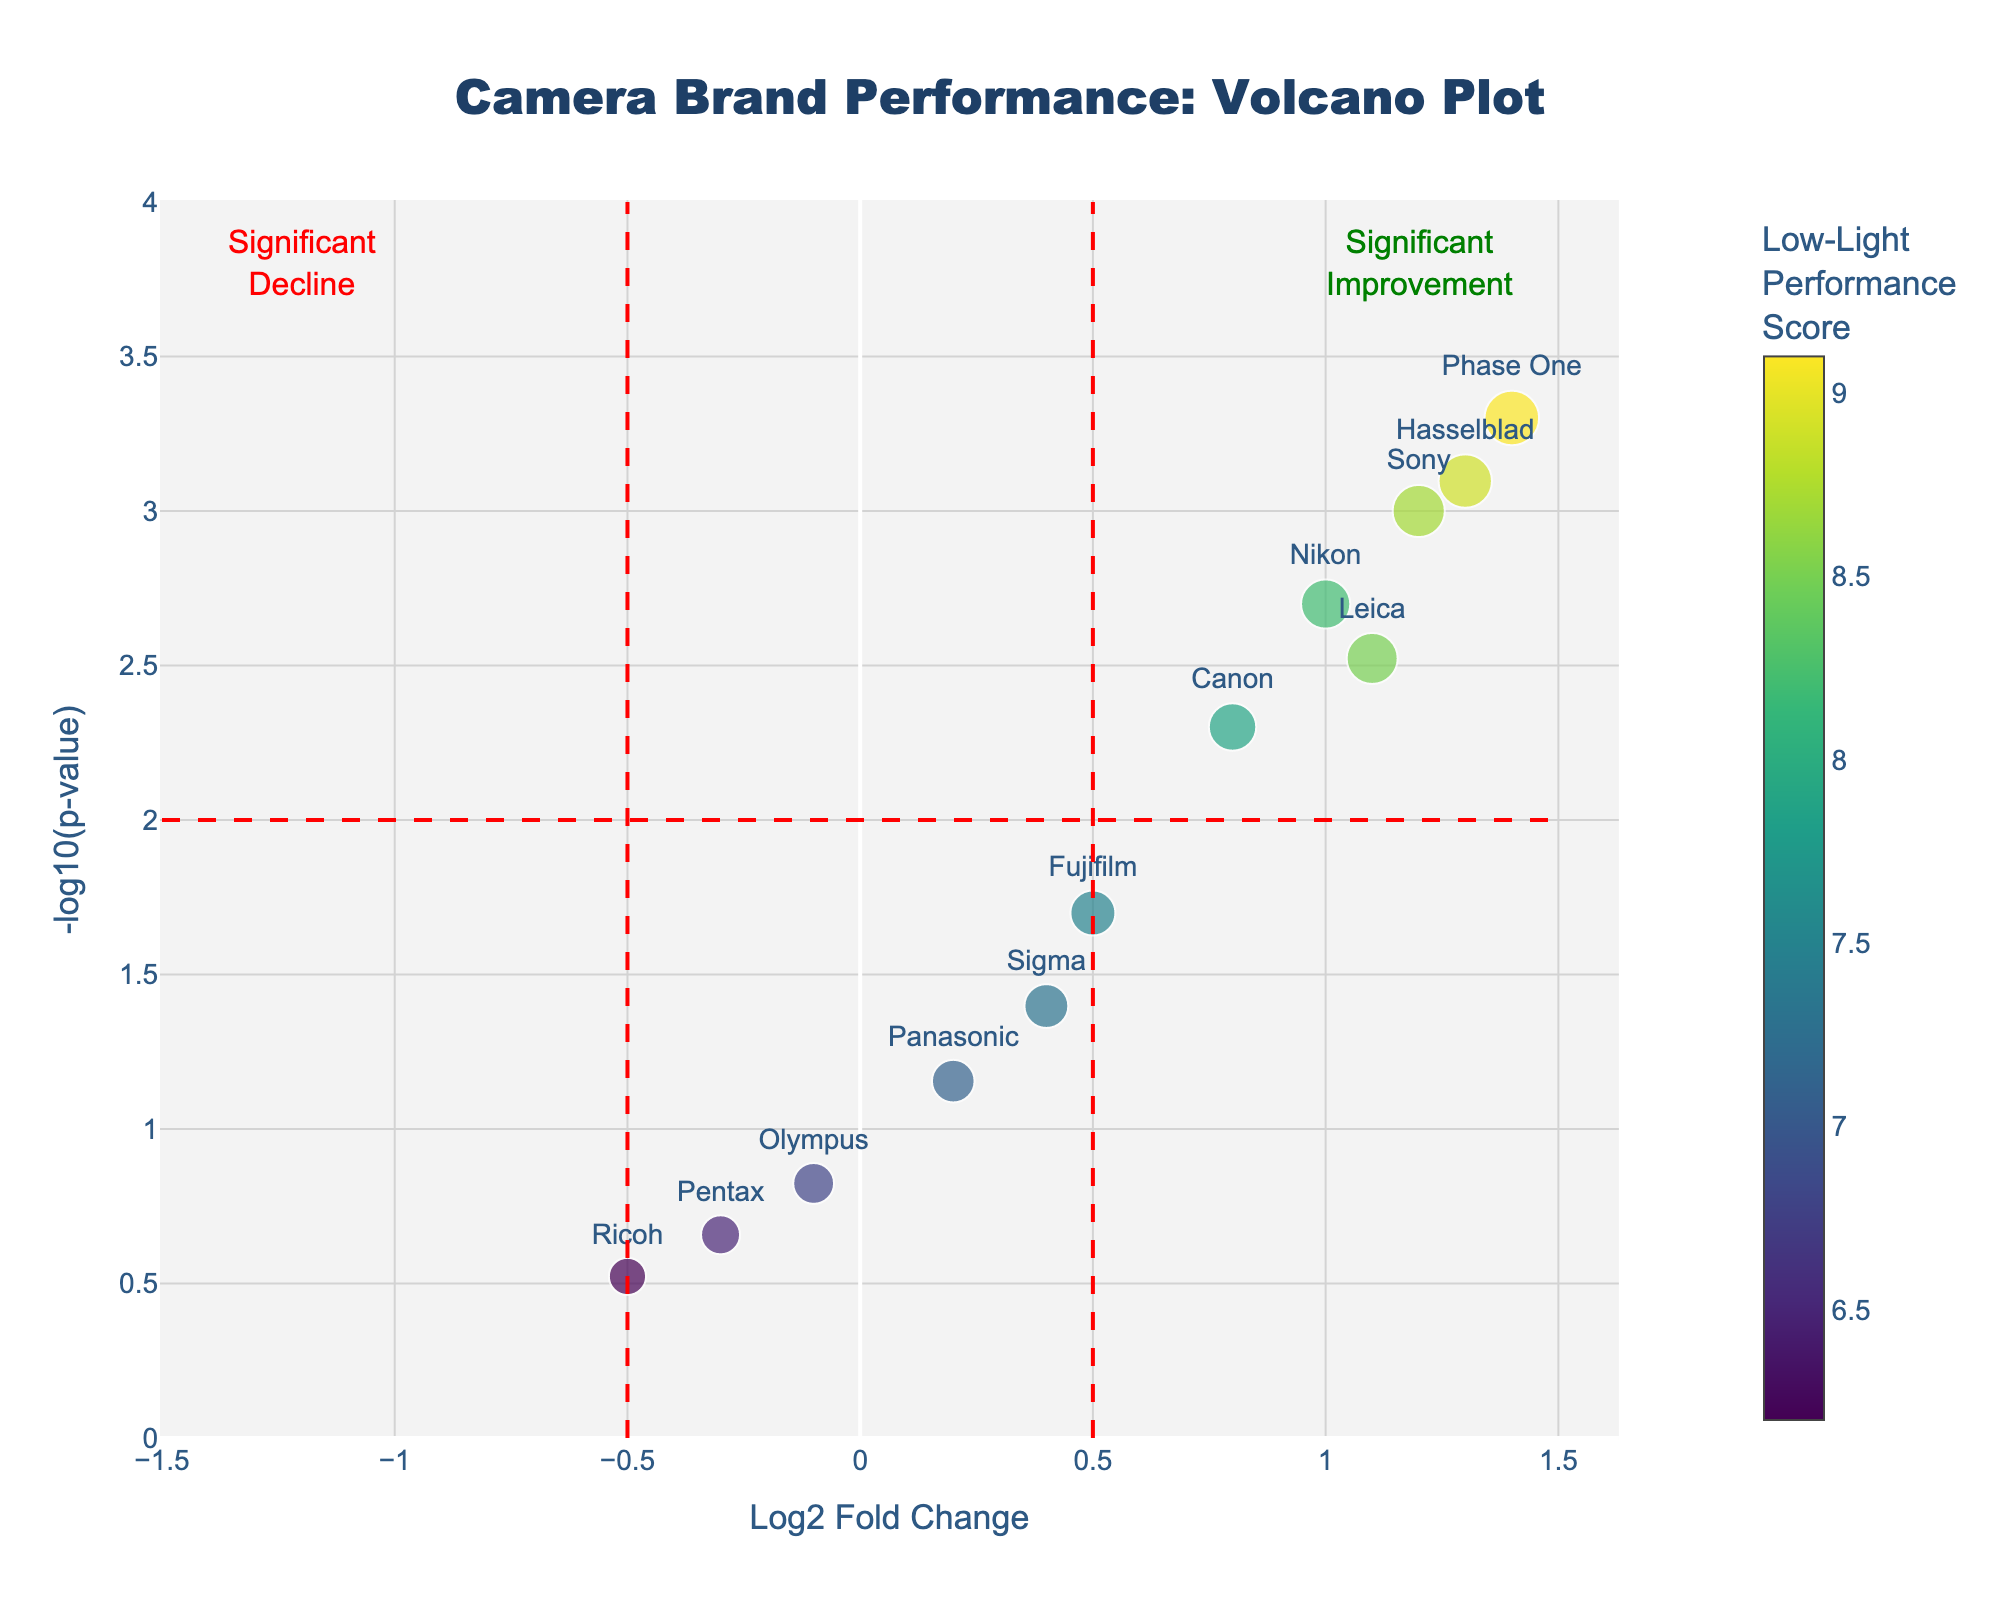What's the title of the plot? The title is presented at the top of the plot, clearly indicating the topic being analyzed.
Answer: Camera Brand Performance: Volcano Plot What does the x-axis represent? The x-axis is labeled "Log2 Fold Change," indicating it shows the Log2 fold change values for different camera brands.
Answer: Log2 Fold Change What does the y-axis represent? The y-axis is labeled "-log10(p-value)," indicating it shows the negative log10 p-values for different camera brands' low-light performance scores.
Answer: -log10(p-value) How many camera brands are represented in the plot? Each point with a label corresponds to a different camera brand. By counting them, we find there are 12 camera brands represented.
Answer: 12 Which camera brand has the highest Low-Light Performance Score? The color bar indicates the color intensity corresponds to the Low-Light Performance Score. By looking at the darkest point, we see “Phase One” with the highest performance score.
Answer: Phase One Which camera brands show significant improvement in low-light capabilities? Brands with significant improvement are in the top-right quadrant (high Log2 Fold Change and high -log10(p-value)). These brands are Sony, Nikon, Leica, Hasselblad, and Phase One.
Answer: Sony, Nikon, Leica, Hasselblad, Phase One Which camera brands show a significant decline in low-light capabilities? Brands with significant decline are in the top-left quadrant (negative Log2 Fold Change and high -log10(p-value)). No points are present in this quadrant, indicating no brands show significant decline.
Answer: None What is the Low-Light Performance Score for Sony and Canon? By hovering or looking directly at the plot, Sony has a score of 8.7, and Canon has 7.9.
Answer: Sony: 8.7, Canon: 7.9 Compare the -log10(p-value) for Fujifilm and Sigma. By observing their positions, Fujifilm has a -log10(p-value) around 1.7 and Sigma around 1.4. Fujifilm has a higher -log10(p-value) than Sigma.
Answer: Fujifilm > Sigma Which camera has the lowest p-value? The lowest p-value corresponds to the highest -log10(p-value). Phase One is at the highest position, indicating it has the lowest p-value.
Answer: Phase One 